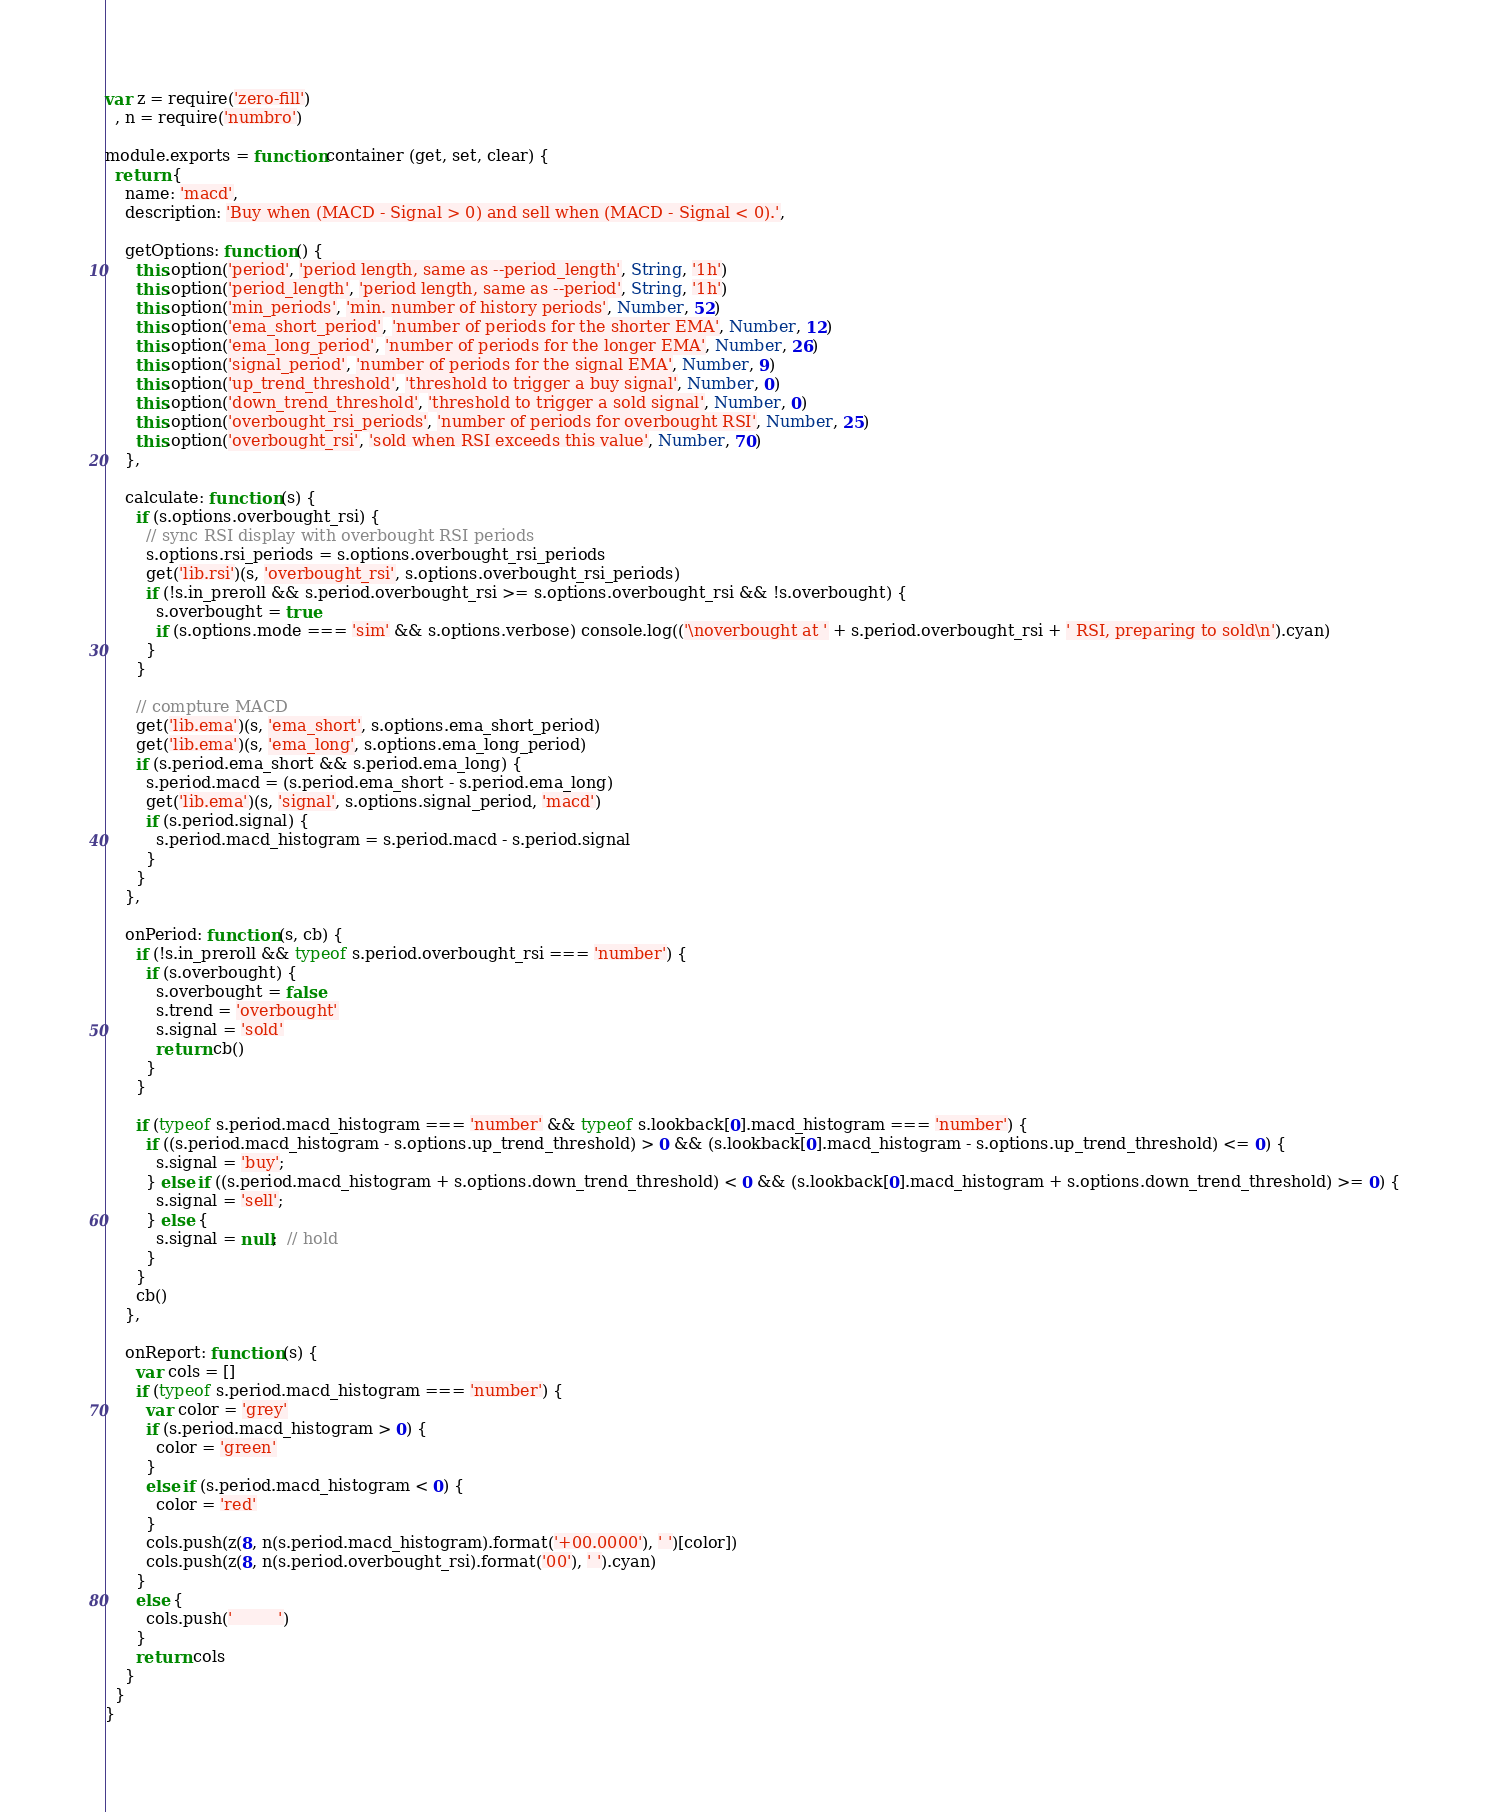<code> <loc_0><loc_0><loc_500><loc_500><_JavaScript_>var z = require('zero-fill')
  , n = require('numbro')

module.exports = function container (get, set, clear) {
  return {
    name: 'macd',
    description: 'Buy when (MACD - Signal > 0) and sell when (MACD - Signal < 0).',

    getOptions: function () {
      this.option('period', 'period length, same as --period_length', String, '1h')
      this.option('period_length', 'period length, same as --period', String, '1h')
      this.option('min_periods', 'min. number of history periods', Number, 52)
      this.option('ema_short_period', 'number of periods for the shorter EMA', Number, 12)
      this.option('ema_long_period', 'number of periods for the longer EMA', Number, 26)
      this.option('signal_period', 'number of periods for the signal EMA', Number, 9)
      this.option('up_trend_threshold', 'threshold to trigger a buy signal', Number, 0)
      this.option('down_trend_threshold', 'threshold to trigger a sold signal', Number, 0)
      this.option('overbought_rsi_periods', 'number of periods for overbought RSI', Number, 25)
      this.option('overbought_rsi', 'sold when RSI exceeds this value', Number, 70)
    },

    calculate: function (s) {
      if (s.options.overbought_rsi) {
        // sync RSI display with overbought RSI periods
        s.options.rsi_periods = s.options.overbought_rsi_periods
        get('lib.rsi')(s, 'overbought_rsi', s.options.overbought_rsi_periods)
        if (!s.in_preroll && s.period.overbought_rsi >= s.options.overbought_rsi && !s.overbought) {
          s.overbought = true
          if (s.options.mode === 'sim' && s.options.verbose) console.log(('\noverbought at ' + s.period.overbought_rsi + ' RSI, preparing to sold\n').cyan)
        }
      }

      // compture MACD
      get('lib.ema')(s, 'ema_short', s.options.ema_short_period)
      get('lib.ema')(s, 'ema_long', s.options.ema_long_period)
      if (s.period.ema_short && s.period.ema_long) {
        s.period.macd = (s.period.ema_short - s.period.ema_long)
        get('lib.ema')(s, 'signal', s.options.signal_period, 'macd')
        if (s.period.signal) {
          s.period.macd_histogram = s.period.macd - s.period.signal
        }
      }
    },

    onPeriod: function (s, cb) {
      if (!s.in_preroll && typeof s.period.overbought_rsi === 'number') {
        if (s.overbought) {
          s.overbought = false
          s.trend = 'overbought'
          s.signal = 'sold'
          return cb()
        }
      }

      if (typeof s.period.macd_histogram === 'number' && typeof s.lookback[0].macd_histogram === 'number') {
        if ((s.period.macd_histogram - s.options.up_trend_threshold) > 0 && (s.lookback[0].macd_histogram - s.options.up_trend_threshold) <= 0) {
          s.signal = 'buy';
        } else if ((s.period.macd_histogram + s.options.down_trend_threshold) < 0 && (s.lookback[0].macd_histogram + s.options.down_trend_threshold) >= 0) {
          s.signal = 'sell';
        } else {
          s.signal = null;  // hold
        }
      }
      cb()
    },

    onReport: function (s) {
      var cols = []
      if (typeof s.period.macd_histogram === 'number') {
        var color = 'grey'
        if (s.period.macd_histogram > 0) {
          color = 'green'
        }
        else if (s.period.macd_histogram < 0) {
          color = 'red'
        }
        cols.push(z(8, n(s.period.macd_histogram).format('+00.0000'), ' ')[color])
        cols.push(z(8, n(s.period.overbought_rsi).format('00'), ' ').cyan)
      }
      else {
        cols.push('         ')
      }
      return cols
    }
  }
}
</code> 